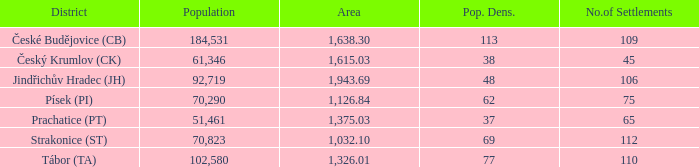How many residential areas are in český krumlov (ck) with a population density above 38? None. 